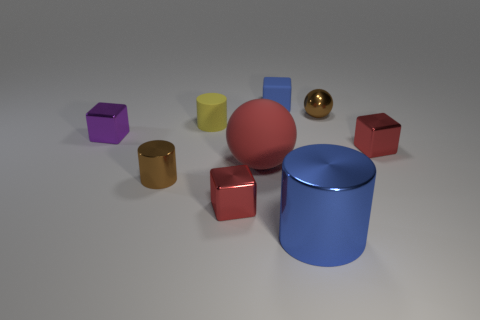Is there a red ball made of the same material as the brown cylinder?
Your response must be concise. No. What is the shape of the metallic thing that is to the right of the blue matte cube and in front of the brown metallic cylinder?
Ensure brevity in your answer.  Cylinder. What number of other objects are there of the same shape as the yellow matte object?
Make the answer very short. 2. What size is the purple cube?
Offer a terse response. Small. How many things are either tiny brown spheres or big red cubes?
Offer a terse response. 1. There is a metal cylinder in front of the small brown shiny cylinder; what is its size?
Provide a short and direct response. Large. Are there any other things that have the same size as the matte block?
Provide a short and direct response. Yes. There is a cylinder that is both behind the big blue metal thing and in front of the red rubber sphere; what is its color?
Give a very brief answer. Brown. Is the brown thing that is in front of the rubber cylinder made of the same material as the blue block?
Ensure brevity in your answer.  No. Does the big metal cylinder have the same color as the tiny cylinder behind the small metallic cylinder?
Provide a short and direct response. No. 